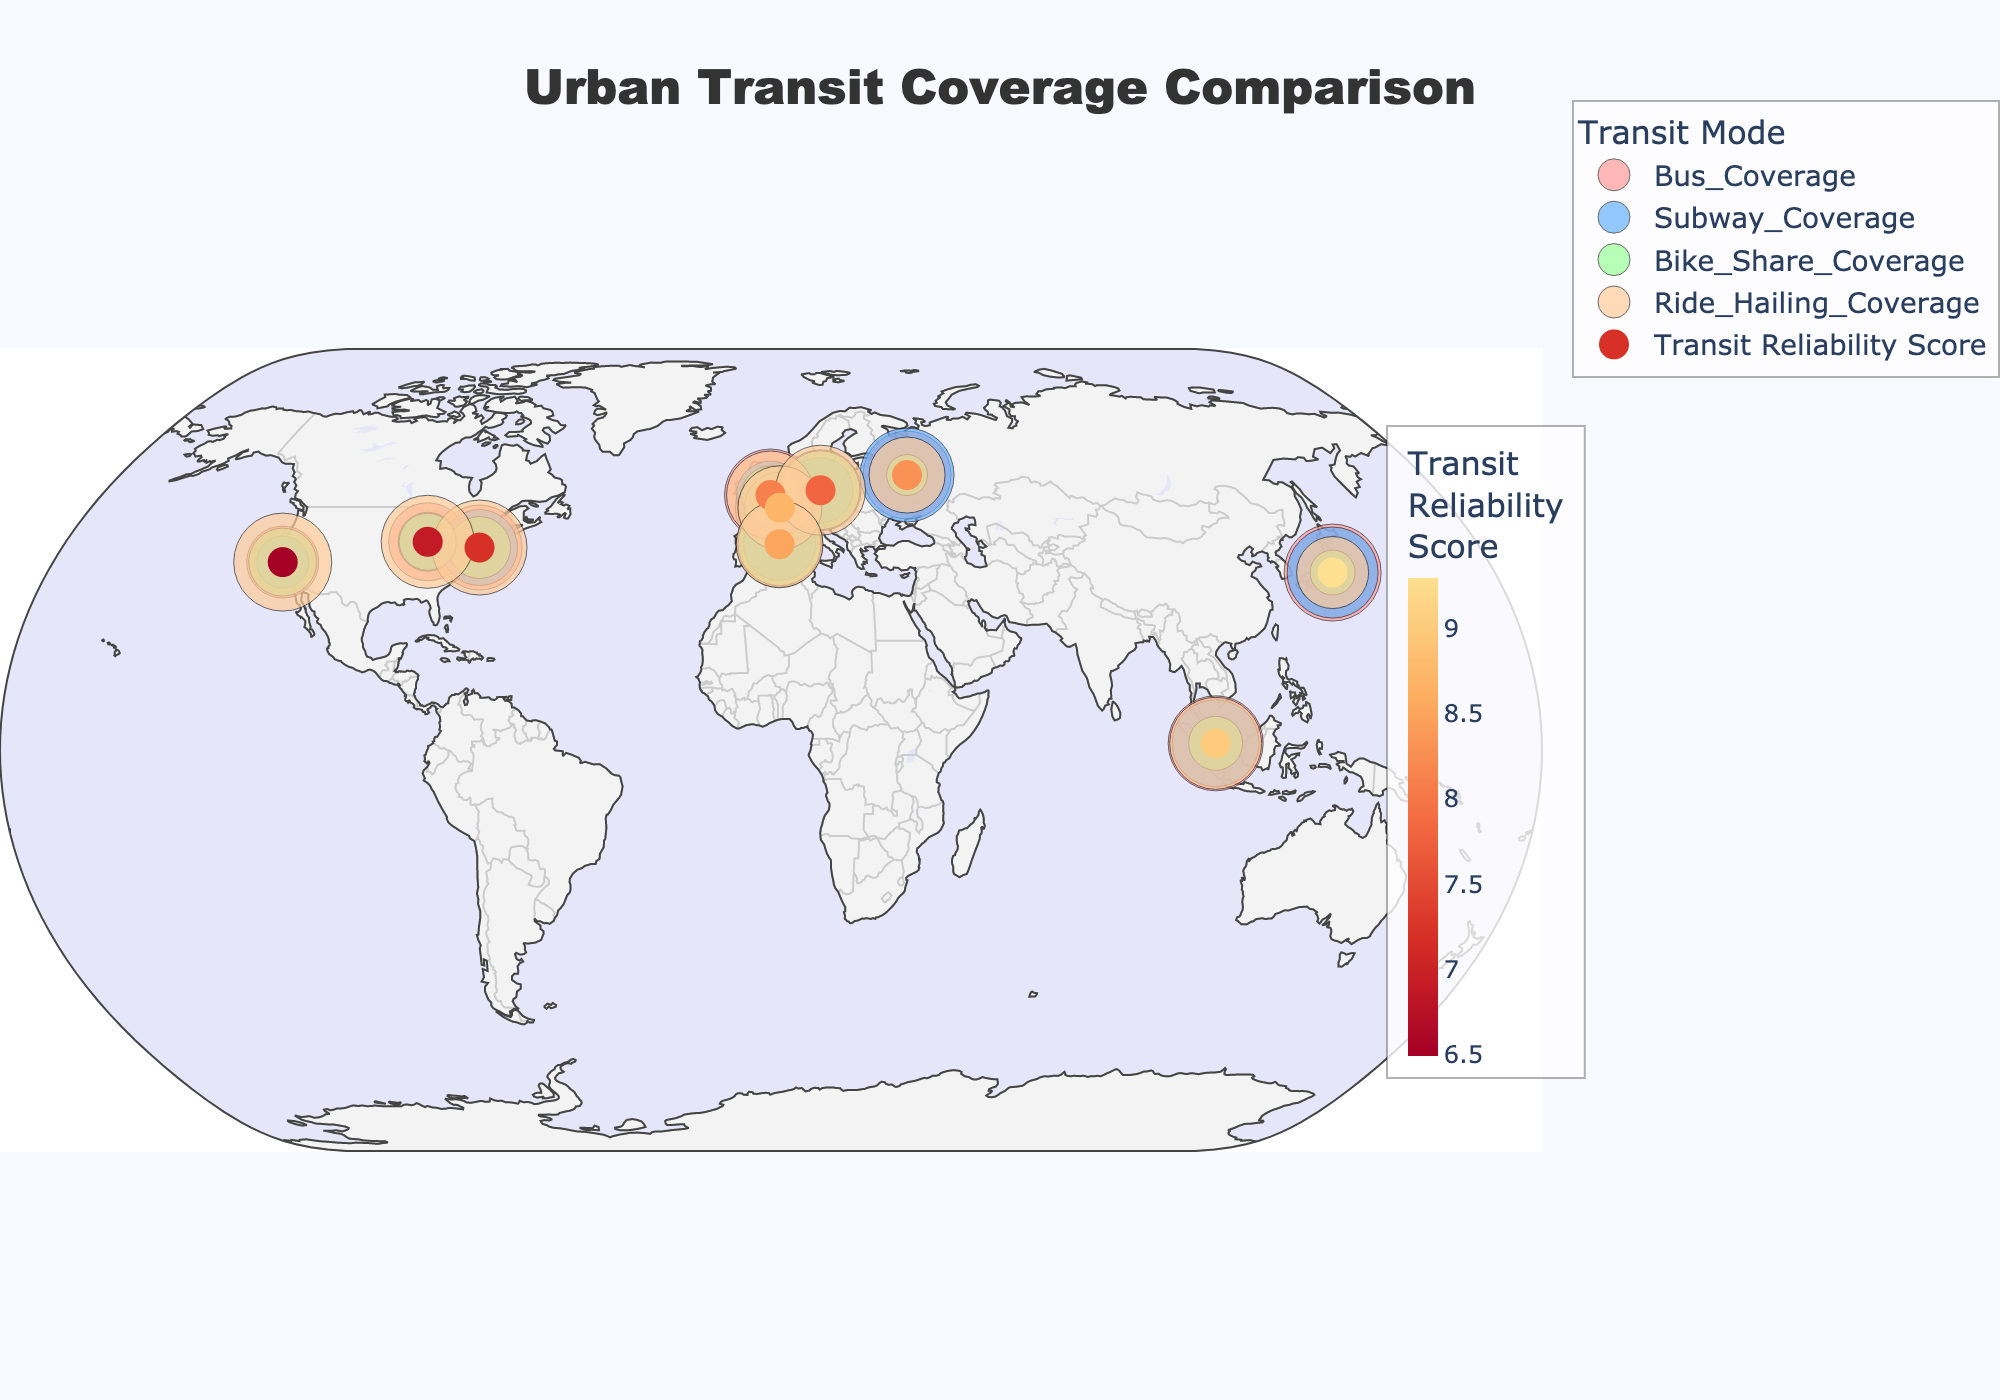What city has the highest bike share coverage? By inspecting the markers representing bike share coverage, we can identify the city with the largest marker in green.
Answer: Berlin Between New York and London, which city has a higher transit reliability score? Check the hover info or the color of the markers related to the transit reliability score for both cities. London has a higher score.
Answer: London What mode of transit is least covered in Paris? By comparing the sizes of markers representing different transit modes for Paris, we find that Bike Share Coverage is relatively smaller compared to the others.
Answer: Bike Share Coverage What is the average transit reliability score of Tokyo, Paris, and Barcelona? Sum the reliability scores of the three cities (9.3 + 8.7 + 8.5 = 26.5) and then divide by 3 to get the average.
Answer: 8.83 Which city has more bus coverage, New York or Chicago? Compare the sizes of the markers representing bus coverage for both cities. New York has a higher bus coverage.
Answer: New York How does San Francisco's subway coverage compare to Moscow's? Look at the size of the markers representing subway coverage for both cities. Moscow has a significantly larger marker, indicating higher coverage.
Answer: Moscow Which city has the highest transit reliability score, and what is that score? Identify the city with the darkest marker in the color bar representing the highest transit reliability score, which is Tokyo with a score of 9.3.
Answer: Tokyo (9.3) If you sum the bike share coverage of London and Berlin, what would that be? Add the bike share coverage values of both cities (58 + 79 = 137).
Answer: 137 